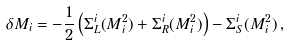<formula> <loc_0><loc_0><loc_500><loc_500>\delta M _ { i } = - \frac { 1 } { 2 } \left ( \Sigma _ { L } ^ { i } ( M _ { i } ^ { 2 } ) + \Sigma _ { R } ^ { i } ( M _ { i } ^ { 2 } ) \right ) - \Sigma _ { S } ^ { i } ( M _ { i } ^ { 2 } ) \, ,</formula> 